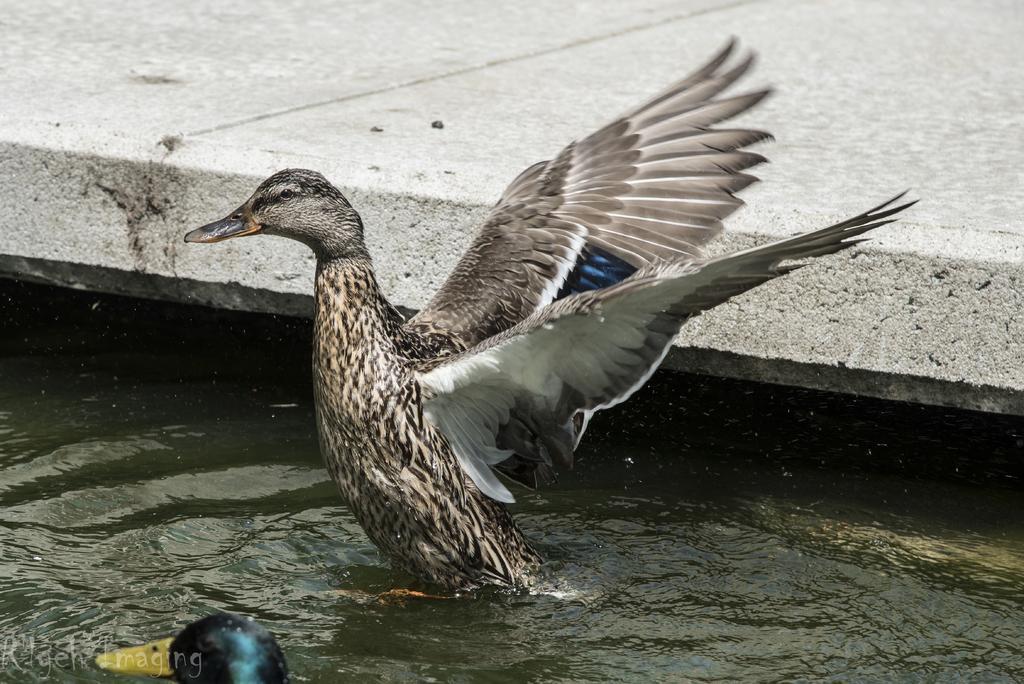Can you describe this image briefly? In this image we can see ducks in the water. In the back there is a concrete slab. In the left bottom corner there is watermark. 